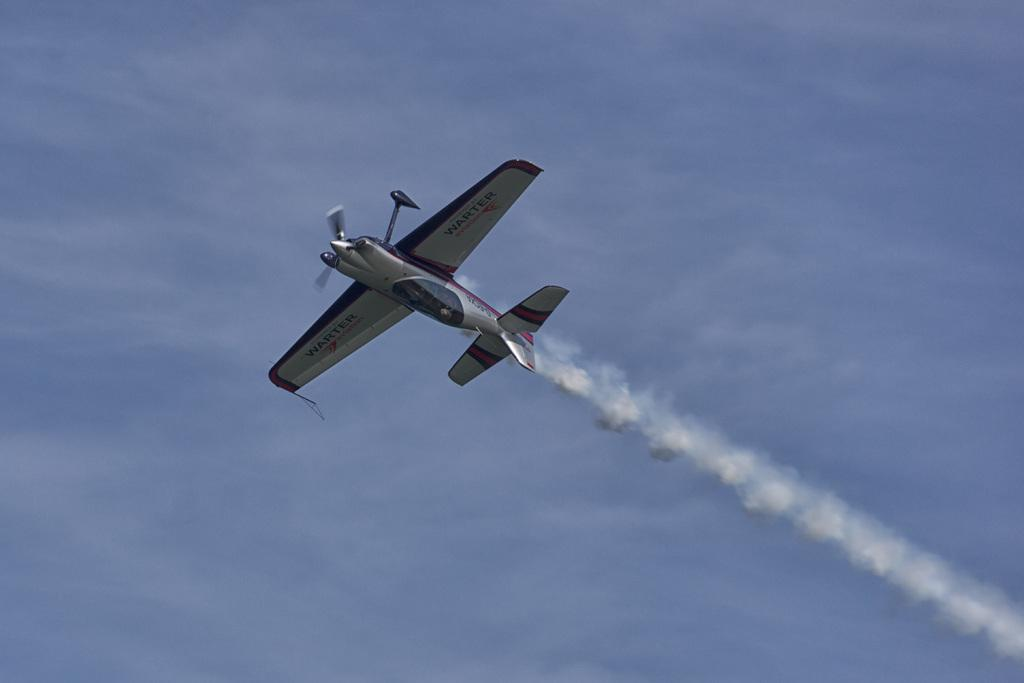What is the main subject in the sky in the image? There is a glider in the sky in the image. What time is the key being used to unlock the route in the image? There is no key or route present in the image; it only features a glider in the sky. 